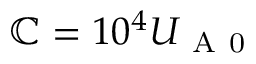<formula> <loc_0><loc_0><loc_500><loc_500>\mathbb { C } = 1 0 ^ { 4 } U _ { A 0 }</formula> 